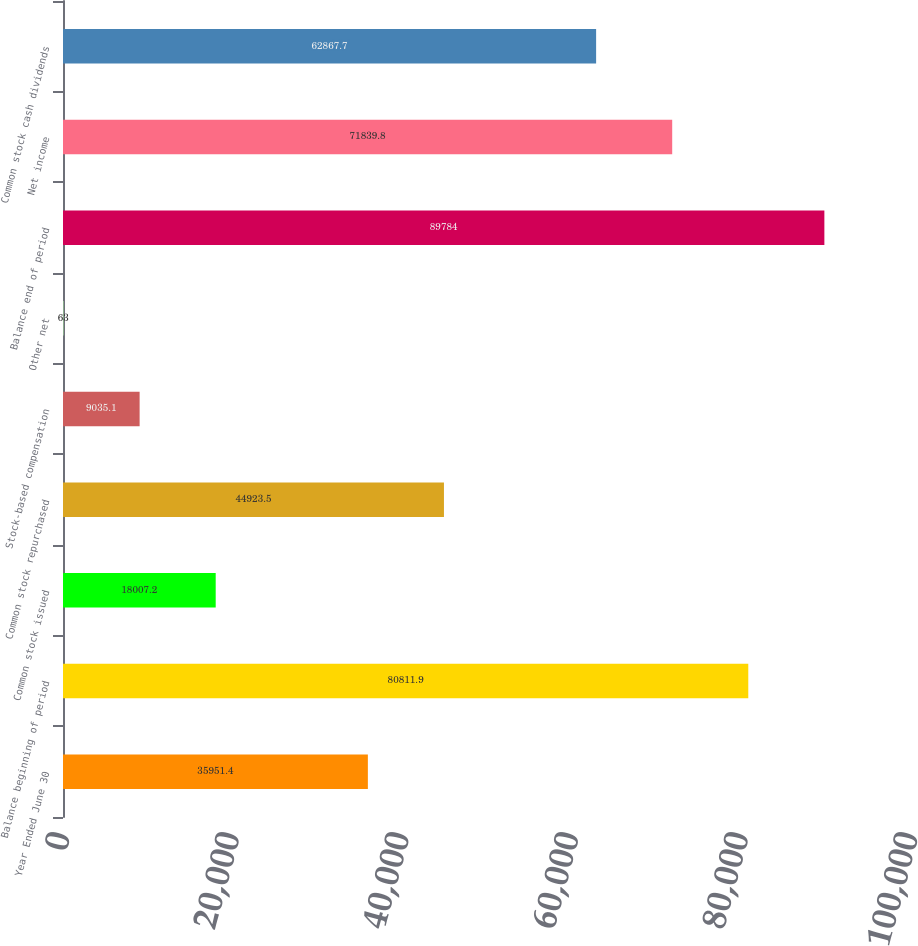<chart> <loc_0><loc_0><loc_500><loc_500><bar_chart><fcel>Year Ended June 30<fcel>Balance beginning of period<fcel>Common stock issued<fcel>Common stock repurchased<fcel>Stock-based compensation<fcel>Other net<fcel>Balance end of period<fcel>Net income<fcel>Common stock cash dividends<nl><fcel>35951.4<fcel>80811.9<fcel>18007.2<fcel>44923.5<fcel>9035.1<fcel>63<fcel>89784<fcel>71839.8<fcel>62867.7<nl></chart> 